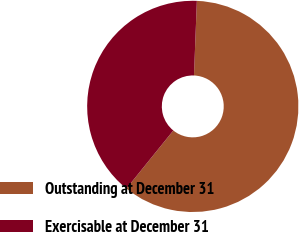Convert chart. <chart><loc_0><loc_0><loc_500><loc_500><pie_chart><fcel>Outstanding at December 31<fcel>Exercisable at December 31<nl><fcel>60.2%<fcel>39.8%<nl></chart> 